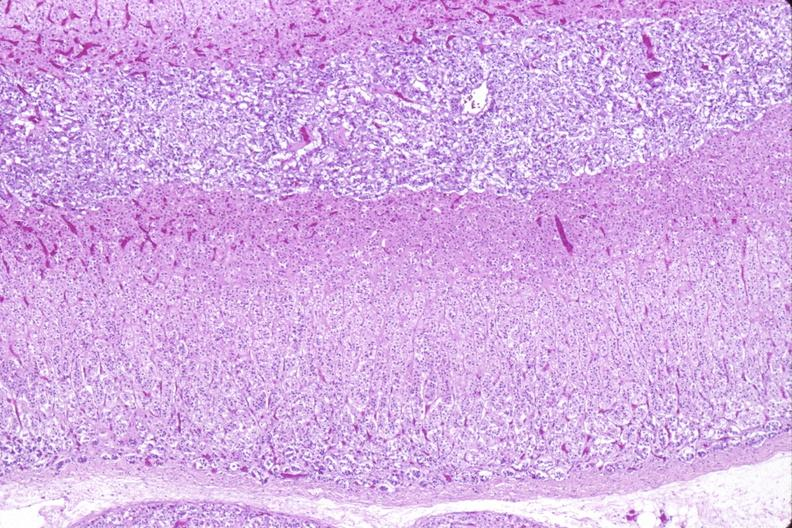s endocrine present?
Answer the question using a single word or phrase. Yes 